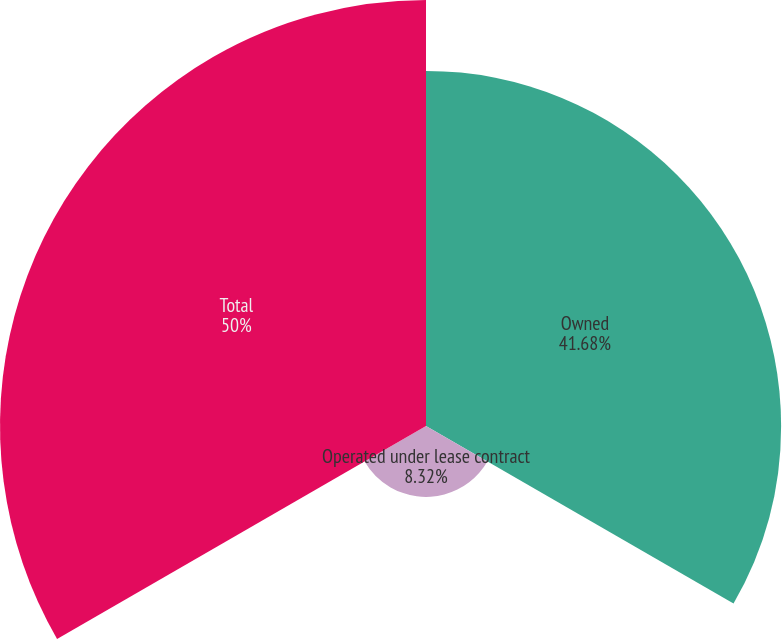Convert chart. <chart><loc_0><loc_0><loc_500><loc_500><pie_chart><fcel>Owned<fcel>Operated under lease contract<fcel>Total<nl><fcel>41.68%<fcel>8.32%<fcel>50.0%<nl></chart> 